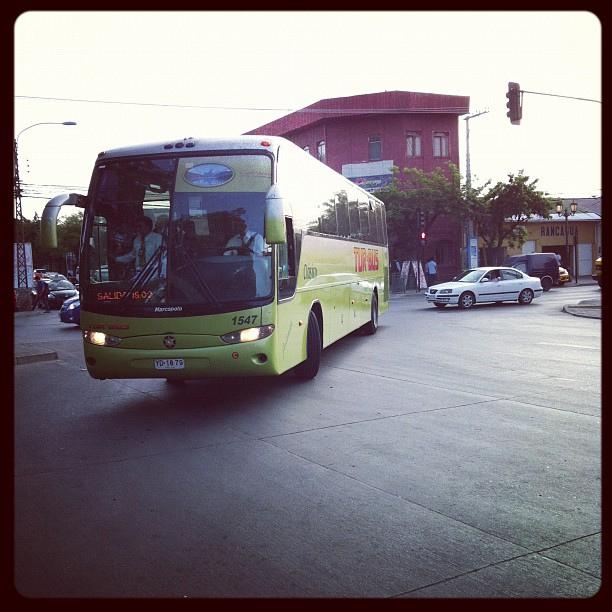Overcast or sunny?
Give a very brief answer. Overcast. What color is the bus driver wearing?
Be succinct. White. Is the bus on a straight forward path?
Answer briefly. No. 